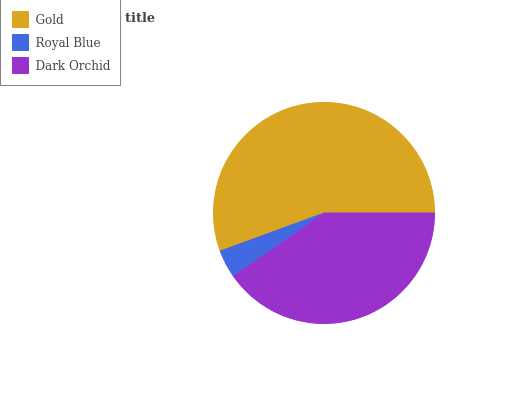Is Royal Blue the minimum?
Answer yes or no. Yes. Is Gold the maximum?
Answer yes or no. Yes. Is Dark Orchid the minimum?
Answer yes or no. No. Is Dark Orchid the maximum?
Answer yes or no. No. Is Dark Orchid greater than Royal Blue?
Answer yes or no. Yes. Is Royal Blue less than Dark Orchid?
Answer yes or no. Yes. Is Royal Blue greater than Dark Orchid?
Answer yes or no. No. Is Dark Orchid less than Royal Blue?
Answer yes or no. No. Is Dark Orchid the high median?
Answer yes or no. Yes. Is Dark Orchid the low median?
Answer yes or no. Yes. Is Royal Blue the high median?
Answer yes or no. No. Is Royal Blue the low median?
Answer yes or no. No. 